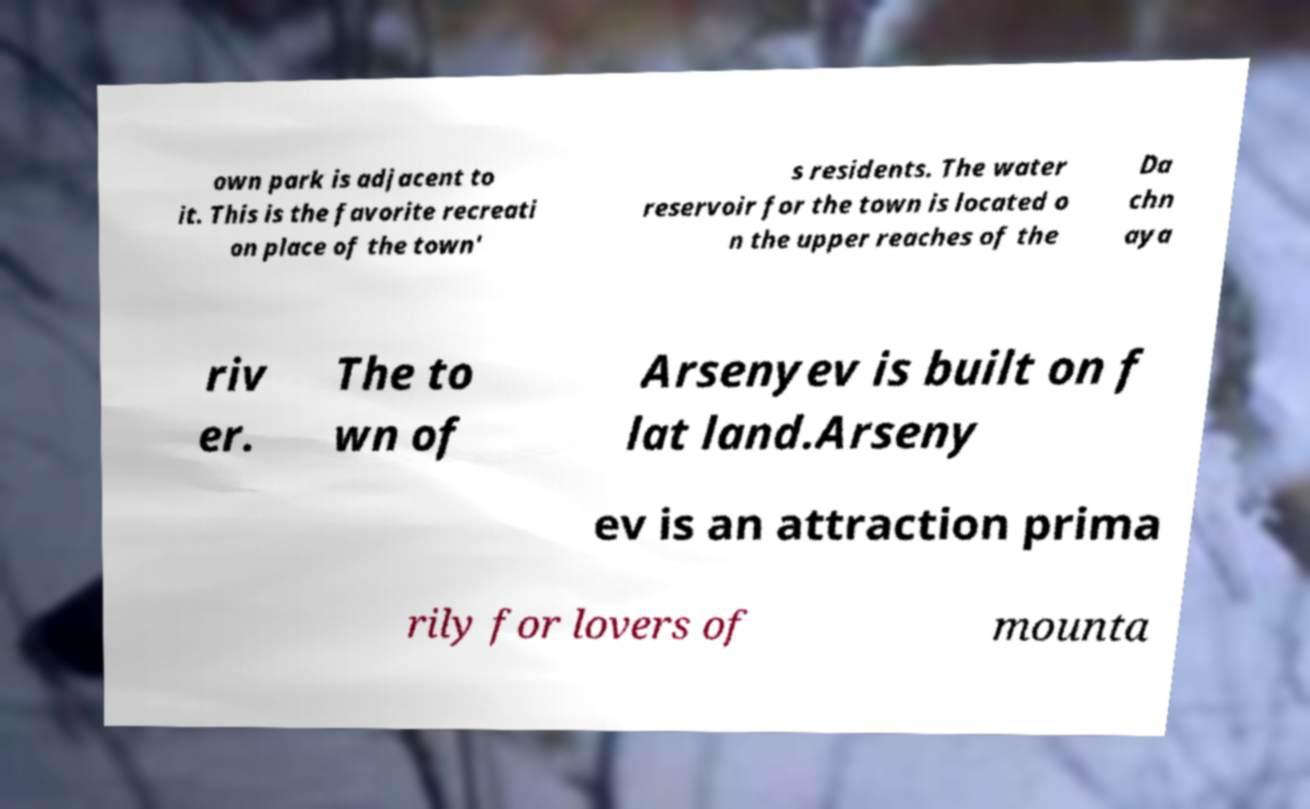Could you extract and type out the text from this image? own park is adjacent to it. This is the favorite recreati on place of the town' s residents. The water reservoir for the town is located o n the upper reaches of the Da chn aya riv er. The to wn of Arsenyev is built on f lat land.Arseny ev is an attraction prima rily for lovers of mounta 